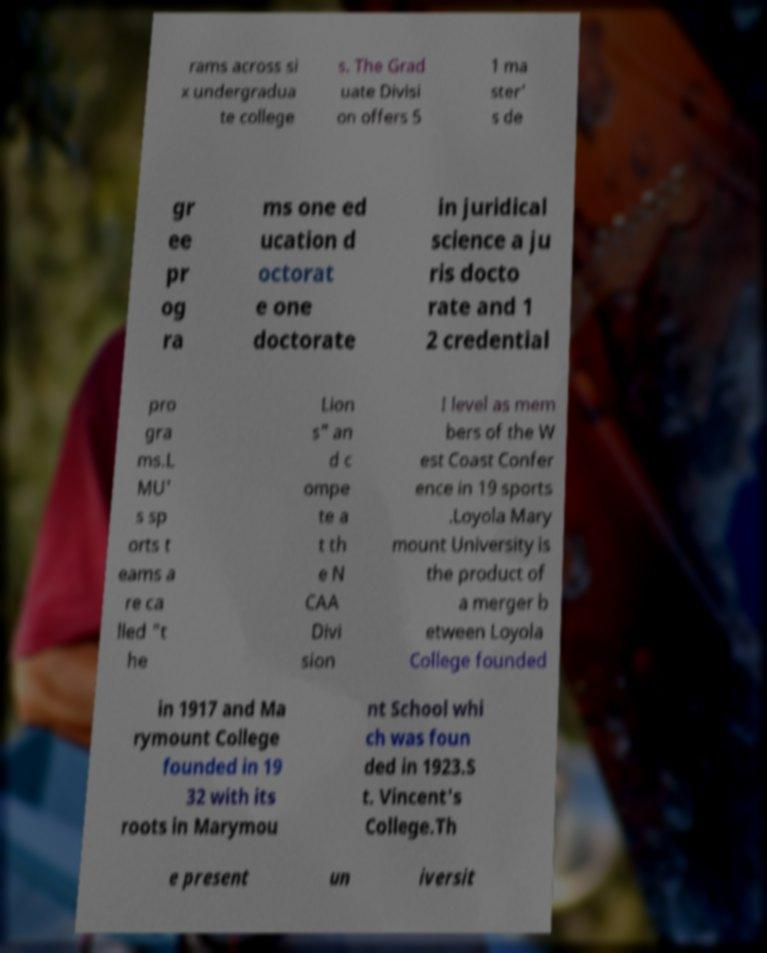What messages or text are displayed in this image? I need them in a readable, typed format. rams across si x undergradua te college s. The Grad uate Divisi on offers 5 1 ma ster' s de gr ee pr og ra ms one ed ucation d octorat e one doctorate in juridical science a ju ris docto rate and 1 2 credential pro gra ms.L MU' s sp orts t eams a re ca lled "t he Lion s" an d c ompe te a t th e N CAA Divi sion I level as mem bers of the W est Coast Confer ence in 19 sports .Loyola Mary mount University is the product of a merger b etween Loyola College founded in 1917 and Ma rymount College founded in 19 32 with its roots in Marymou nt School whi ch was foun ded in 1923.S t. Vincent's College.Th e present un iversit 